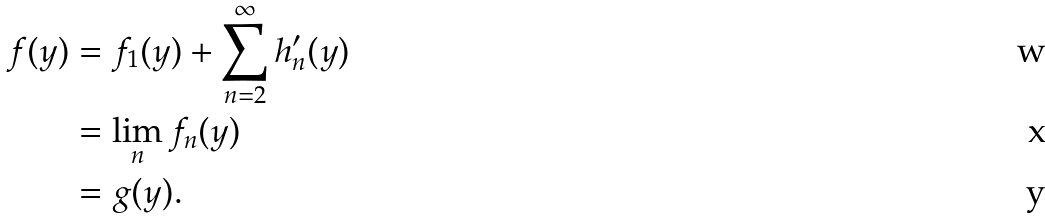<formula> <loc_0><loc_0><loc_500><loc_500>f ( y ) & = f _ { 1 } ( y ) + \sum _ { n = 2 } ^ { \infty } h _ { n } ^ { \prime } ( y ) \\ & = \lim _ { n } f _ { n } ( y ) \\ & = g ( y ) .</formula> 